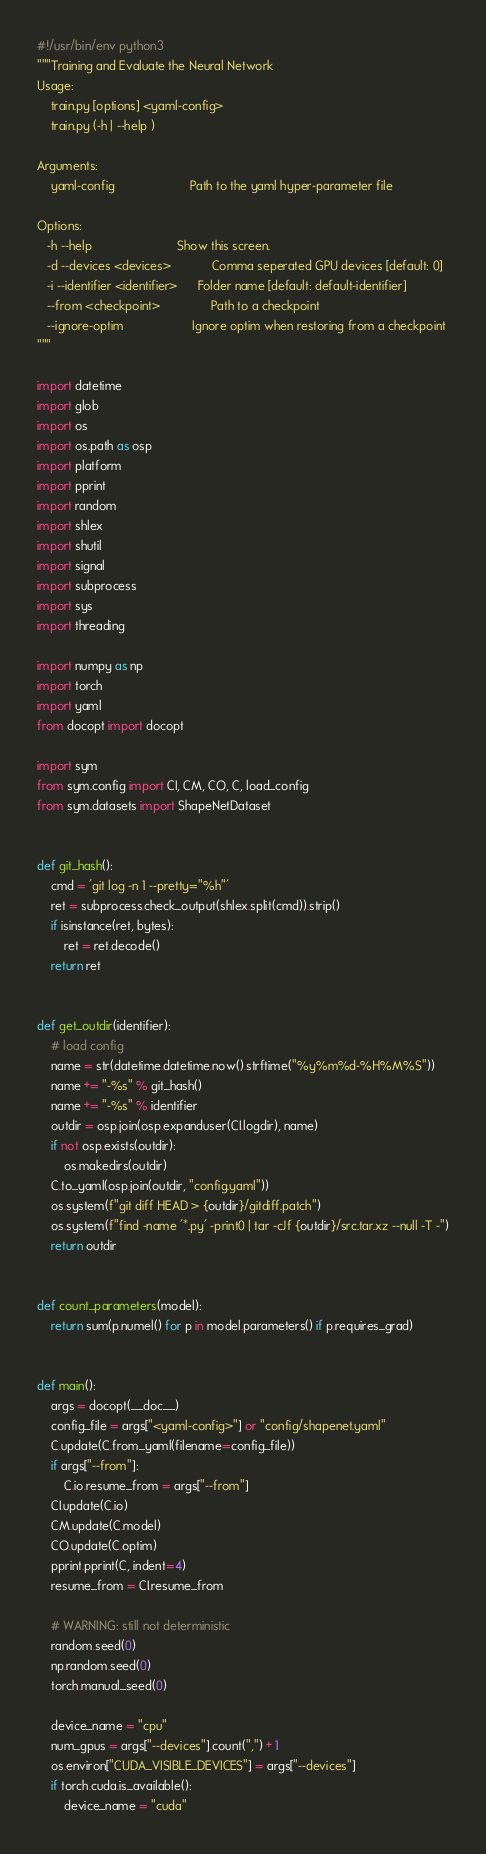<code> <loc_0><loc_0><loc_500><loc_500><_Python_>#!/usr/bin/env python3
"""Training and Evaluate the Neural Network
Usage:
    train.py [options] <yaml-config>
    train.py (-h | --help )

Arguments:
    yaml-config                      Path to the yaml hyper-parameter file

Options:
   -h --help                         Show this screen.
   -d --devices <devices>            Comma seperated GPU devices [default: 0]
   -i --identifier <identifier>      Folder name [default: default-identifier]
   --from <checkpoint>               Path to a checkpoint
   --ignore-optim                    Ignore optim when restoring from a checkpoint
"""

import datetime
import glob
import os
import os.path as osp
import platform
import pprint
import random
import shlex
import shutil
import signal
import subprocess
import sys
import threading

import numpy as np
import torch
import yaml
from docopt import docopt

import sym
from sym.config import CI, CM, CO, C, load_config
from sym.datasets import ShapeNetDataset


def git_hash():
    cmd = 'git log -n 1 --pretty="%h"'
    ret = subprocess.check_output(shlex.split(cmd)).strip()
    if isinstance(ret, bytes):
        ret = ret.decode()
    return ret


def get_outdir(identifier):
    # load config
    name = str(datetime.datetime.now().strftime("%y%m%d-%H%M%S"))
    name += "-%s" % git_hash()
    name += "-%s" % identifier
    outdir = osp.join(osp.expanduser(CI.logdir), name)
    if not osp.exists(outdir):
        os.makedirs(outdir)
    C.to_yaml(osp.join(outdir, "config.yaml"))
    os.system(f"git diff HEAD > {outdir}/gitdiff.patch")
    os.system(f"find -name '*.py' -print0 | tar -cJf {outdir}/src.tar.xz --null -T -")
    return outdir


def count_parameters(model):
    return sum(p.numel() for p in model.parameters() if p.requires_grad)


def main():
    args = docopt(__doc__)
    config_file = args["<yaml-config>"] or "config/shapenet.yaml"
    C.update(C.from_yaml(filename=config_file))
    if args["--from"]:
        C.io.resume_from = args["--from"]
    CI.update(C.io)
    CM.update(C.model)
    CO.update(C.optim)
    pprint.pprint(C, indent=4)
    resume_from = CI.resume_from

    # WARNING: still not deterministic
    random.seed(0)
    np.random.seed(0)
    torch.manual_seed(0)

    device_name = "cpu"
    num_gpus = args["--devices"].count(",") + 1
    os.environ["CUDA_VISIBLE_DEVICES"] = args["--devices"]
    if torch.cuda.is_available():
        device_name = "cuda"</code> 